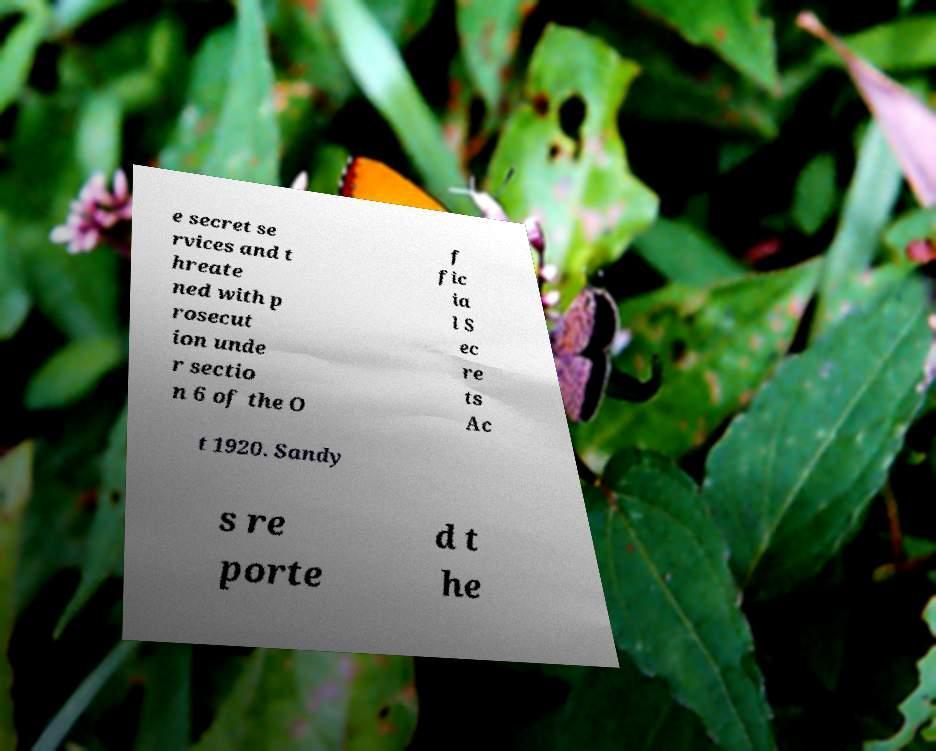Could you extract and type out the text from this image? e secret se rvices and t hreate ned with p rosecut ion unde r sectio n 6 of the O f fic ia l S ec re ts Ac t 1920. Sandy s re porte d t he 